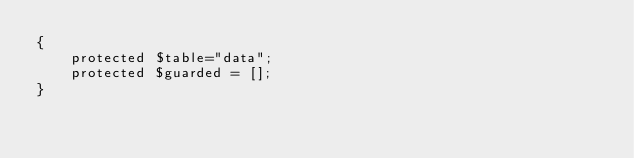Convert code to text. <code><loc_0><loc_0><loc_500><loc_500><_PHP_>{
    protected $table="data";
    protected $guarded = [];
}
</code> 